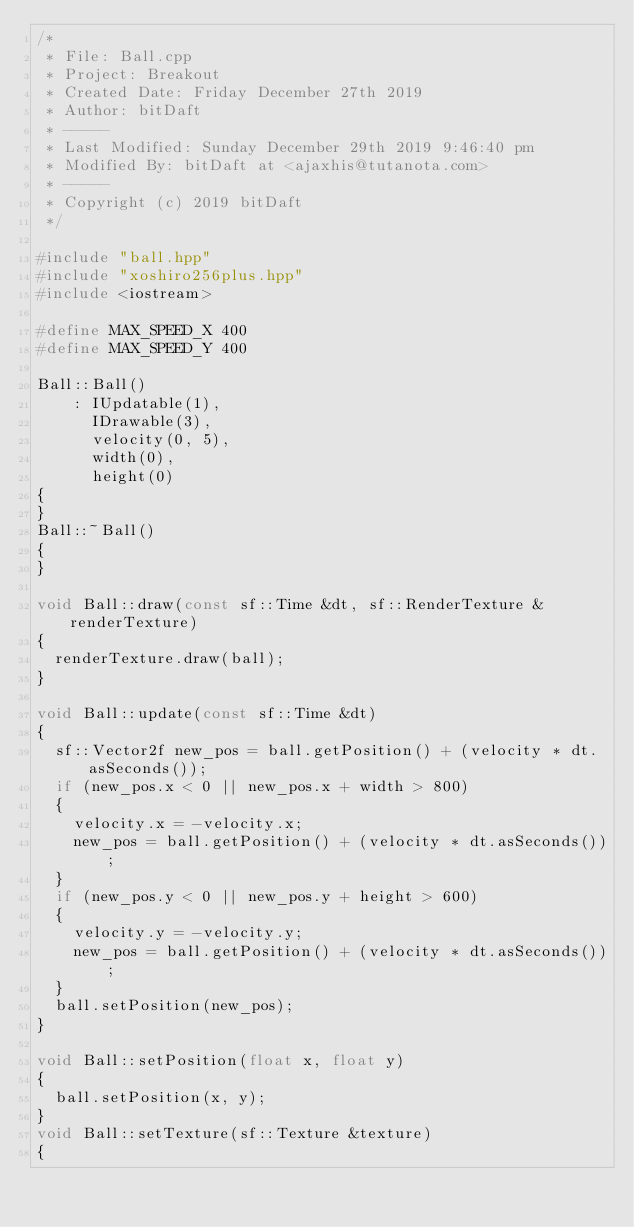Convert code to text. <code><loc_0><loc_0><loc_500><loc_500><_C++_>/*
 * File: Ball.cpp
 * Project: Breakout
 * Created Date: Friday December 27th 2019
 * Author: bitDaft
 * -----
 * Last Modified: Sunday December 29th 2019 9:46:40 pm
 * Modified By: bitDaft at <ajaxhis@tutanota.com>
 * -----
 * Copyright (c) 2019 bitDaft
 */

#include "ball.hpp"
#include "xoshiro256plus.hpp"
#include <iostream>

#define MAX_SPEED_X 400
#define MAX_SPEED_Y 400

Ball::Ball()
    : IUpdatable(1),
      IDrawable(3),
      velocity(0, 5),
      width(0),
      height(0)
{
}
Ball::~Ball()
{
}

void Ball::draw(const sf::Time &dt, sf::RenderTexture &renderTexture)
{
  renderTexture.draw(ball);
}

void Ball::update(const sf::Time &dt)
{
  sf::Vector2f new_pos = ball.getPosition() + (velocity * dt.asSeconds());
  if (new_pos.x < 0 || new_pos.x + width > 800)
  {
    velocity.x = -velocity.x;
    new_pos = ball.getPosition() + (velocity * dt.asSeconds());
  }
  if (new_pos.y < 0 || new_pos.y + height > 600)
  {
    velocity.y = -velocity.y;
    new_pos = ball.getPosition() + (velocity * dt.asSeconds());
  }
  ball.setPosition(new_pos);
}

void Ball::setPosition(float x, float y)
{
  ball.setPosition(x, y);
}
void Ball::setTexture(sf::Texture &texture)
{</code> 